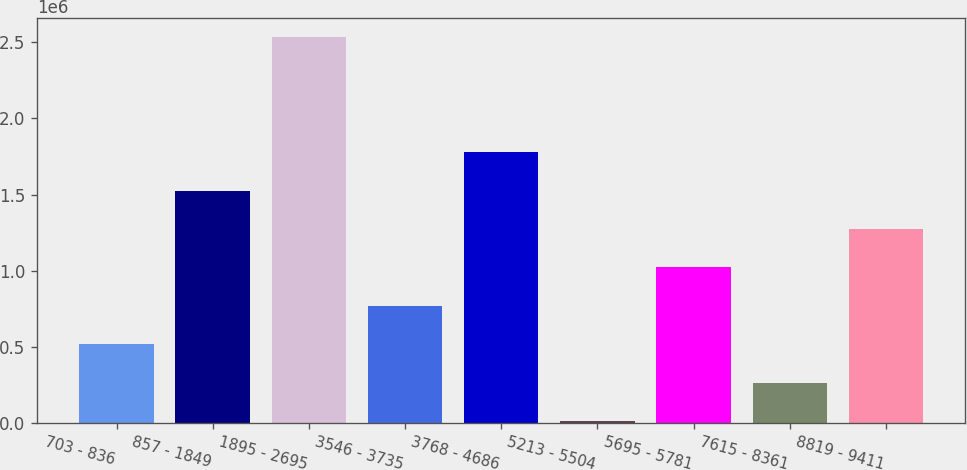Convert chart to OTSL. <chart><loc_0><loc_0><loc_500><loc_500><bar_chart><fcel>703 - 836<fcel>857 - 1849<fcel>1895 - 2695<fcel>3546 - 3735<fcel>3768 - 4686<fcel>5213 - 5504<fcel>5695 - 5781<fcel>7615 - 8361<fcel>8819 - 9411<nl><fcel>516737<fcel>1.52601e+06<fcel>2.53529e+06<fcel>769056<fcel>1.77833e+06<fcel>12100<fcel>1.02137e+06<fcel>264419<fcel>1.27369e+06<nl></chart> 